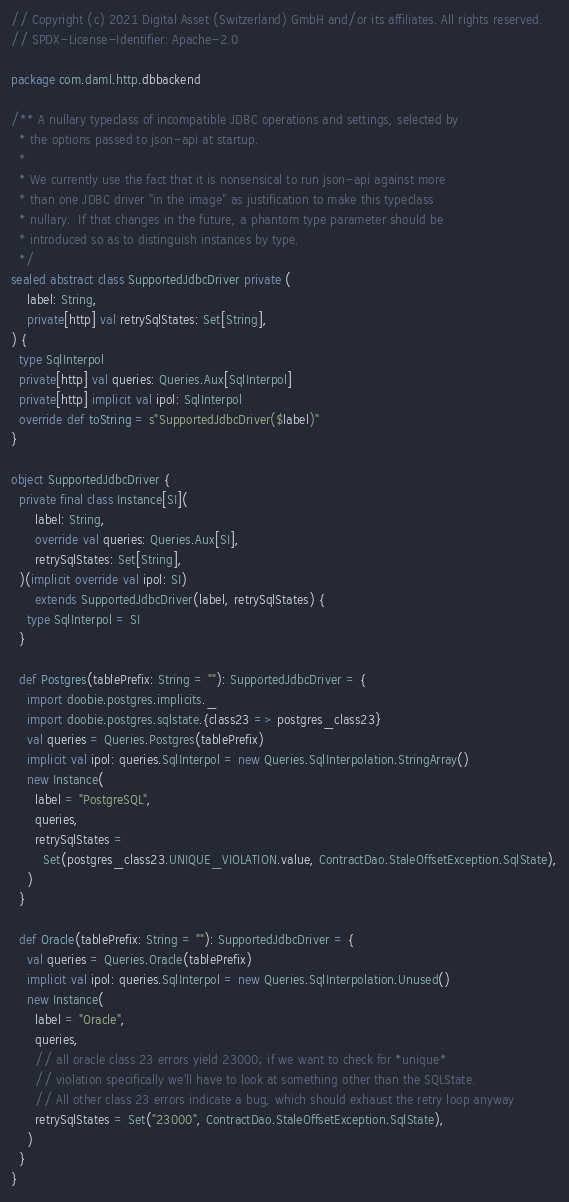<code> <loc_0><loc_0><loc_500><loc_500><_Scala_>// Copyright (c) 2021 Digital Asset (Switzerland) GmbH and/or its affiliates. All rights reserved.
// SPDX-License-Identifier: Apache-2.0

package com.daml.http.dbbackend

/** A nullary typeclass of incompatible JDBC operations and settings, selected by
  * the options passed to json-api at startup.
  *
  * We currently use the fact that it is nonsensical to run json-api against more
  * than one JDBC driver ''in the image'' as justification to make this typeclass
  * nullary.  If that changes in the future, a phantom type parameter should be
  * introduced so as to distinguish instances by type.
  */
sealed abstract class SupportedJdbcDriver private (
    label: String,
    private[http] val retrySqlStates: Set[String],
) {
  type SqlInterpol
  private[http] val queries: Queries.Aux[SqlInterpol]
  private[http] implicit val ipol: SqlInterpol
  override def toString = s"SupportedJdbcDriver($label)"
}

object SupportedJdbcDriver {
  private final class Instance[SI](
      label: String,
      override val queries: Queries.Aux[SI],
      retrySqlStates: Set[String],
  )(implicit override val ipol: SI)
      extends SupportedJdbcDriver(label, retrySqlStates) {
    type SqlInterpol = SI
  }

  def Postgres(tablePrefix: String = ""): SupportedJdbcDriver = {
    import doobie.postgres.implicits._
    import doobie.postgres.sqlstate.{class23 => postgres_class23}
    val queries = Queries.Postgres(tablePrefix)
    implicit val ipol: queries.SqlInterpol = new Queries.SqlInterpolation.StringArray()
    new Instance(
      label = "PostgreSQL",
      queries,
      retrySqlStates =
        Set(postgres_class23.UNIQUE_VIOLATION.value, ContractDao.StaleOffsetException.SqlState),
    )
  }

  def Oracle(tablePrefix: String = ""): SupportedJdbcDriver = {
    val queries = Queries.Oracle(tablePrefix)
    implicit val ipol: queries.SqlInterpol = new Queries.SqlInterpolation.Unused()
    new Instance(
      label = "Oracle",
      queries,
      // all oracle class 23 errors yield 23000; if we want to check for *unique*
      // violation specifically we'll have to look at something other than the SQLState.
      // All other class 23 errors indicate a bug, which should exhaust the retry loop anyway
      retrySqlStates = Set("23000", ContractDao.StaleOffsetException.SqlState),
    )
  }
}
</code> 